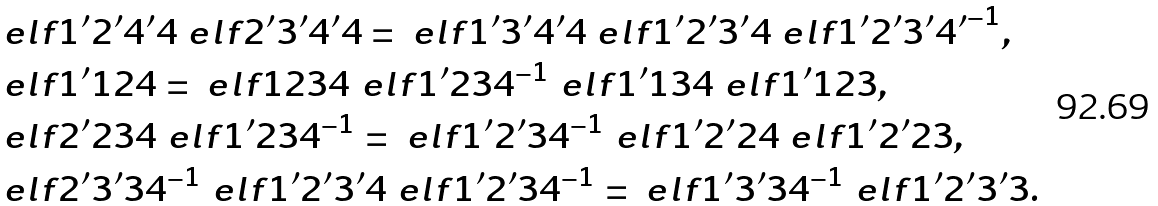Convert formula to latex. <formula><loc_0><loc_0><loc_500><loc_500>& \ e l f { 1 ^ { \prime } } { 2 ^ { \prime } } { 4 ^ { \prime } } { 4 } \ e l f { 2 ^ { \prime } } { 3 ^ { \prime } } { 4 ^ { \prime } } { 4 } = \ e l f { 1 ^ { \prime } } { 3 ^ { \prime } } { 4 ^ { \prime } } { 4 } \ e l f { 1 ^ { \prime } } { 2 ^ { \prime } } { 3 ^ { \prime } } { 4 } \ e l f { 1 ^ { \prime } } { 2 ^ { \prime } } { 3 ^ { \prime } } { 4 ^ { \prime } } ^ { - 1 } , \\ & \ e l f { 1 ^ { \prime } } { 1 } { 2 } { 4 } = \ e l f { 1 } { 2 } { 3 } { 4 } \ e l f { 1 ^ { \prime } } { 2 } { 3 } { 4 } ^ { - 1 } \ e l f { 1 ^ { \prime } } { 1 } { 3 } { 4 } \ e l f { 1 ^ { \prime } } { 1 } { 2 } { 3 } , \\ & \ e l f { 2 ^ { \prime } } { 2 } { 3 } { 4 } \ e l f { 1 ^ { \prime } } { 2 } { 3 } { 4 } ^ { - 1 } = \ e l f { 1 ^ { \prime } } { 2 ^ { \prime } } { 3 } { 4 } ^ { - 1 } \ e l f { 1 ^ { \prime } } { 2 ^ { \prime } } { 2 } { 4 } \ e l f { 1 ^ { \prime } } { 2 ^ { \prime } } { 2 } { 3 } , \\ & \ e l f { 2 ^ { \prime } } { 3 ^ { \prime } } { 3 } { 4 } ^ { - 1 } \ e l f { 1 ^ { \prime } } { 2 ^ { \prime } } { 3 ^ { \prime } } { 4 } \ e l f { 1 ^ { \prime } } { 2 ^ { \prime } } { 3 } { 4 } ^ { - 1 } = \ e l f { 1 ^ { \prime } } { 3 ^ { \prime } } { 3 } { 4 } ^ { - 1 } \ e l f { 1 ^ { \prime } } { 2 ^ { \prime } } { 3 ^ { \prime } } { 3 } .</formula> 